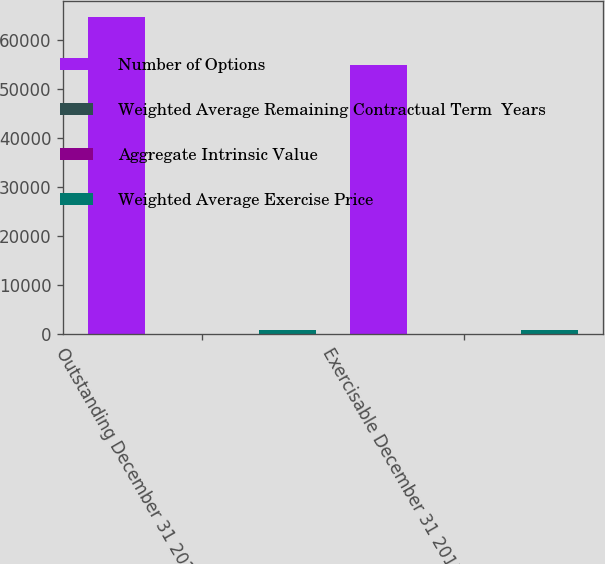Convert chart to OTSL. <chart><loc_0><loc_0><loc_500><loc_500><stacked_bar_chart><ecel><fcel>Outstanding December 31 2015<fcel>Exercisable December 31 2015<nl><fcel>Number of Options<fcel>64668<fcel>54990<nl><fcel>Weighted Average Remaining Contractual Term  Years<fcel>41.64<fcel>39.12<nl><fcel>Aggregate Intrinsic Value<fcel>3.71<fcel>2.87<nl><fcel>Weighted Average Exercise Price<fcel>785<fcel>765<nl></chart> 